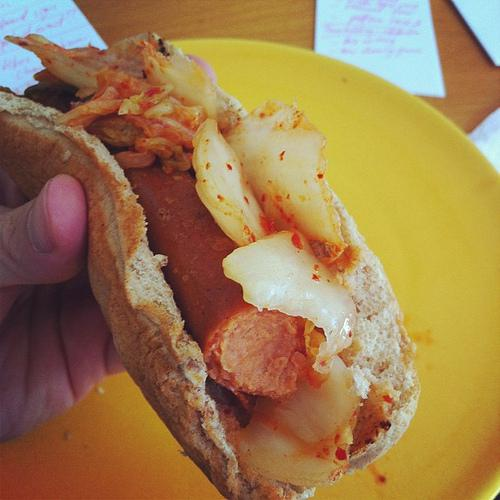Question: when will the check be given?
Choices:
A. After the ceremony.
B. Before the receipt.
C. After the meal.
D. The next morning.
Answer with the letter. Answer: C Question: what color is the plate?
Choices:
A. Yellow.
B. Red.
C. Green.
D. Blue.
Answer with the letter. Answer: A Question: what else is on the dog?
Choices:
A. A collar.
B. Onions.
C. Burrs.
D. Fleas.
Answer with the letter. Answer: B 